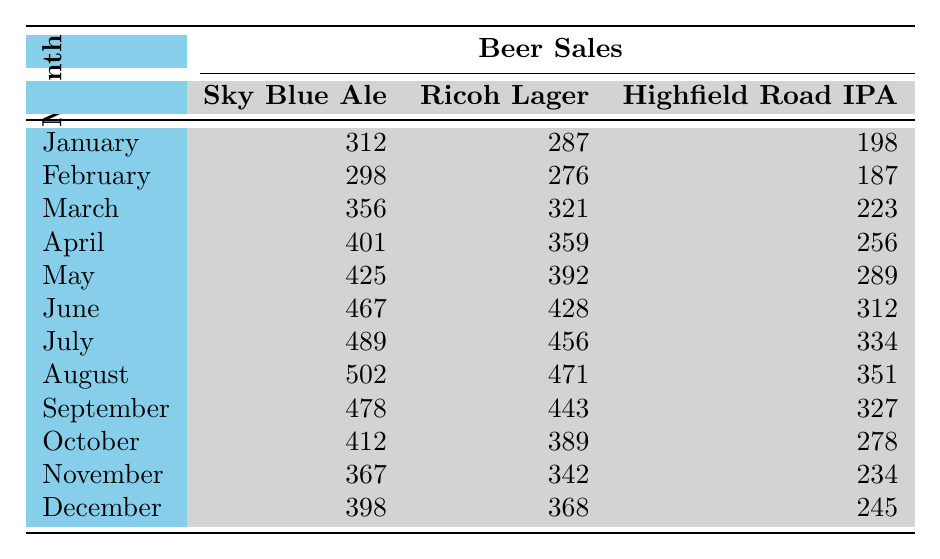What is the total number of Sky Blue Ale sold in June? The table shows that 467 units of Sky Blue Ale were sold in June.
Answer: 467 Which beer had the highest sales in August? In August, Sky Blue Ale had sales of 502, which is higher than Ricoh Lager (471) and Highfield Road IPA (351).
Answer: Sky Blue Ale What is the average sales of Highfield Road IPA over the year? The sales for Highfield Road IPA are: 198, 187, 223, 256, 289, 312, 334, 351, 327, 278, 234, 245. Adding them gives 3,287. There are 12 months, so the average is 3,287 / 12 = approximately 273.92.
Answer: Approximately 274 Did Ricoh Lager outsell Sky Blue Ale in any month? Comparing the monthly sales, Ricoh Lager never outsold Sky Blue Ale as its sales in each month were lower than Sky Blue Ale's.
Answer: No What month had the greatest increase in sales for Sky Blue Ale compared to the previous month? The sales for Sky Blue Ale increased from 401 in April to 425 in May (+24), but the largest increase was from May to June, where it went from 425 to 467 (+42).
Answer: June What was the percentage increase in sales for Ricoh Lager from January to December? The sales for Ricoh Lager increased from 287 in January to 368 in December. The increase is 368 - 287 = 81. The percentage increase is (81 / 287) * 100 ≈ 28.23%.
Answer: Approximately 28.23% In which month did Highfield Road IPA see its lowest sales? Highfield Road IPA had its lowest sales in February with 187 units sold.
Answer: February What was the difference in sales between the highest and lowest selling beers in March? In March, Sky Blue Ale sold 356 and Highfield Road IPA sold 223. The difference is 356 - 223 = 133.
Answer: 133 Which beer consistently sold the most throughout the year? Sky Blue Ale sold more than both Ricoh Lager and Highfield Road IPA in every month listed.
Answer: Sky Blue Ale During which month did Ricoh Lager and Sky Blue Ale have their closest sales figures? In November, Sky Blue Ale sold 367 and Ricoh Lager sold 342, making the difference 367 - 342 = 25, which is the smallest difference throughout the year.
Answer: November How many total beers were sold in December across all types? In December, Sky Blue Ale sold 398, Ricoh Lager sold 368, and Highfield Road IPA sold 245. The total is 398 + 368 + 245 = 1011.
Answer: 1011 